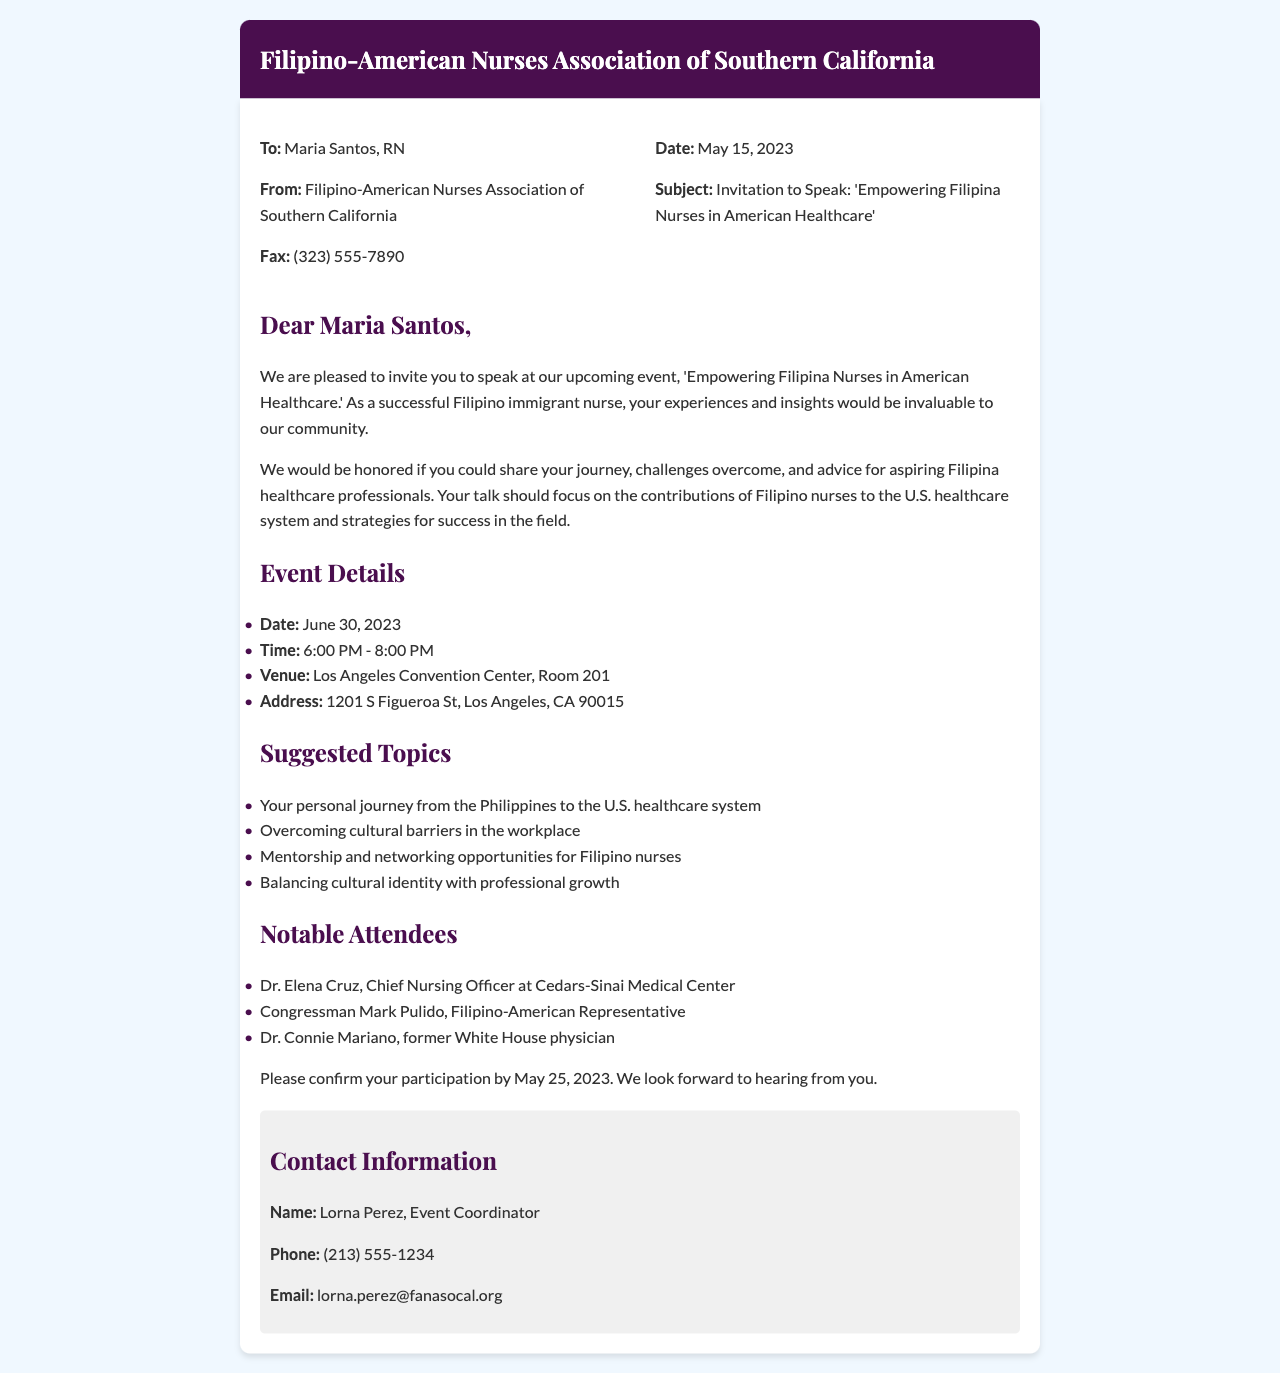what is the name of the organization sending the invitation? The name of the organization is stated at the top of the fax.
Answer: Filipino-American Nurses Association of Southern California who is the intended recipient of the fax? The recipient's name is included in the 'To:' section of the fax.
Answer: Maria Santos, RN when is the deadline for confirming participation? The confirmation deadline is explicitly mentioned in the last section of the fax.
Answer: May 25, 2023 what is the date and time of the event? The event date and time are listed in the 'Event Details' section of the fax.
Answer: June 30, 2023, 6:00 PM - 8:00 PM who is the event coordinator? The name of the event coordinator is mentioned in the 'Contact Information' section.
Answer: Lorna Perez what are two suggested topics for the talk? The suggested topics can be found in the 'Suggested Topics' section, and two examples can be picked.
Answer: Personal journey from the Philippines to the U.S. healthcare system, Overcoming cultural barriers in the workplace how many notable attendees are listed in the document? The number of notable attendees is calculated by counting the entries in the 'Notable Attendees' section.
Answer: Three what is the address of the event venue? The address is provided under 'Event Details' in the fax.
Answer: 1201 S Figueroa St, Los Angeles, CA 90015 what is the purpose of the invitation? The purpose is stated in the introductory paragraph of the fax.
Answer: To speak at the event 'Empowering Filipina Nurses in American Healthcare' 